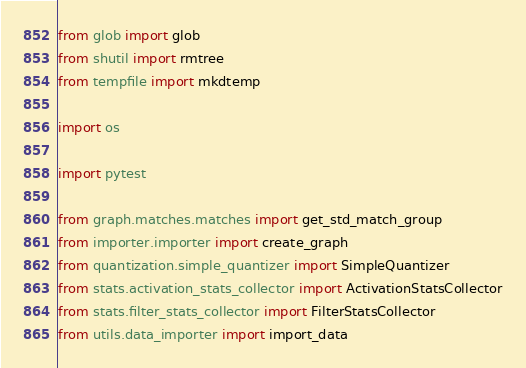Convert code to text. <code><loc_0><loc_0><loc_500><loc_500><_Python_>from glob import glob
from shutil import rmtree
from tempfile import mkdtemp

import os

import pytest

from graph.matches.matches import get_std_match_group
from importer.importer import create_graph
from quantization.simple_quantizer import SimpleQuantizer
from stats.activation_stats_collector import ActivationStatsCollector
from stats.filter_stats_collector import FilterStatsCollector
from utils.data_importer import import_data</code> 